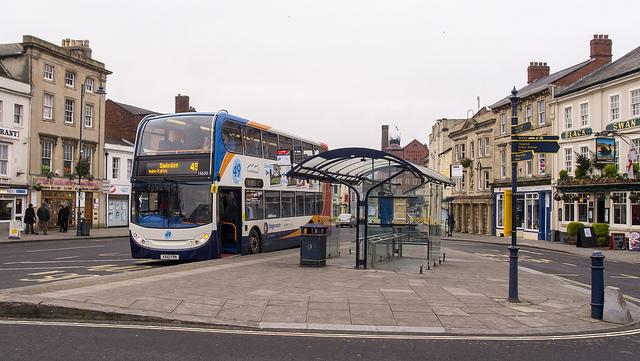What is the round blue bin used to collect? Please explain your reasoning. trash. The bin in the middle of the road is a trash bin. 